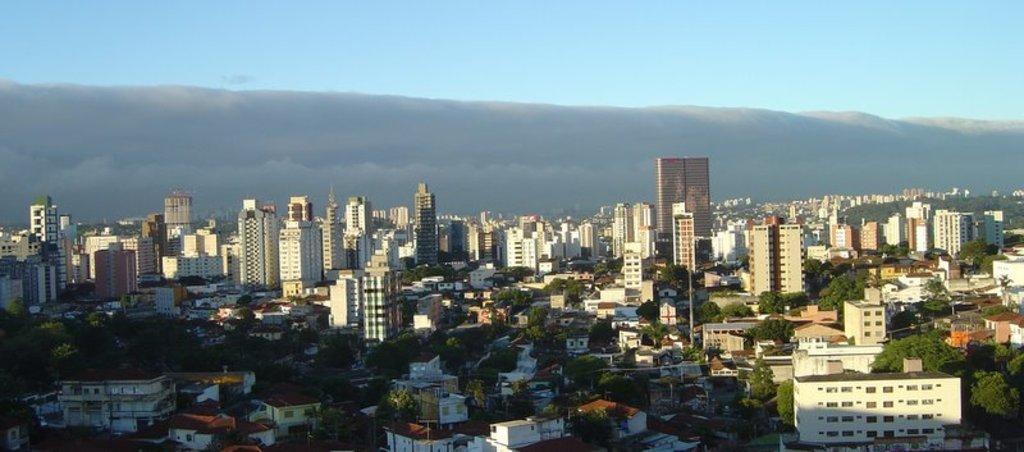Could you give a brief overview of what you see in this image? In this image I can see few buildings, windows, trees, poles and the sky is in grey and blue color. 